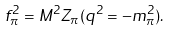<formula> <loc_0><loc_0><loc_500><loc_500>f _ { \pi } ^ { 2 } = M ^ { 2 } Z _ { \pi } ( q ^ { 2 } = - m _ { \pi } ^ { 2 } ) .</formula> 